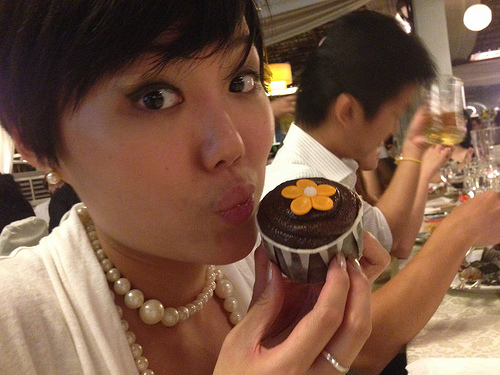Is there a chair or a cell phone in the image? No, there are no chairs or cell phones visible in this image. 